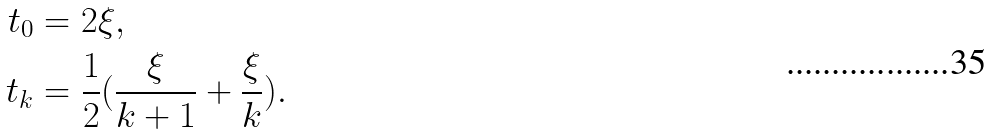<formula> <loc_0><loc_0><loc_500><loc_500>t _ { 0 } & = 2 \xi , \\ t _ { k } & = \frac { 1 } { 2 } ( \frac { \xi } { k + 1 } + \frac { \xi } { k } ) .</formula> 